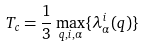Convert formula to latex. <formula><loc_0><loc_0><loc_500><loc_500>T _ { c } = \frac { 1 } { 3 } \max _ { { q } , i , \alpha } \{ \lambda _ { \alpha } ^ { i } ( { q } ) \}</formula> 